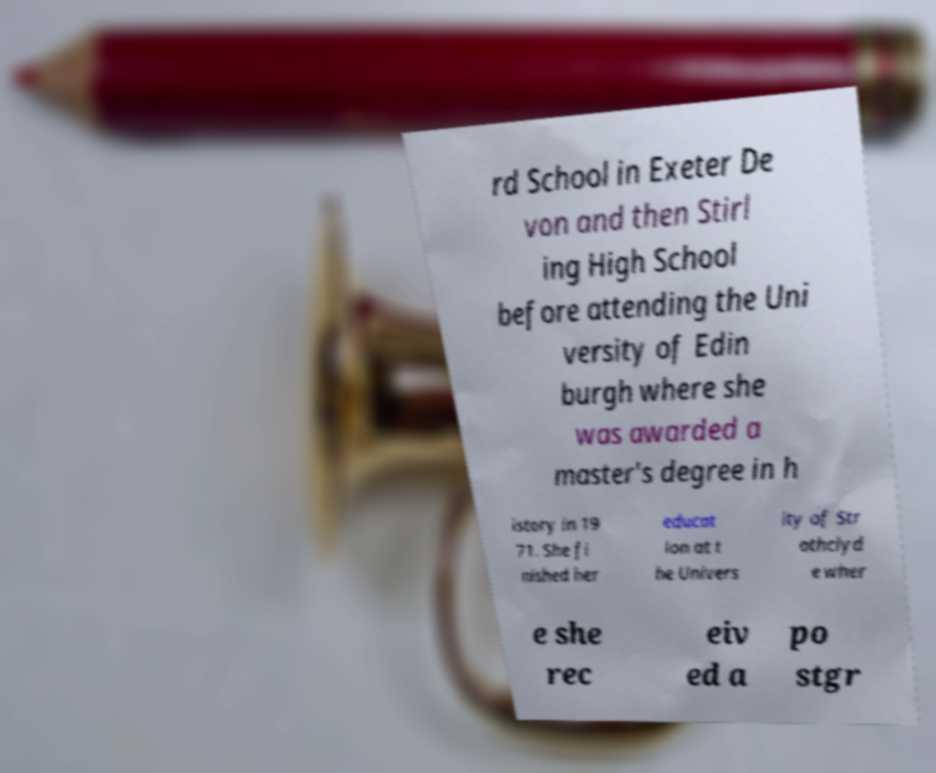What messages or text are displayed in this image? I need them in a readable, typed format. rd School in Exeter De von and then Stirl ing High School before attending the Uni versity of Edin burgh where she was awarded a master's degree in h istory in 19 71. She fi nished her educat ion at t he Univers ity of Str athclyd e wher e she rec eiv ed a po stgr 